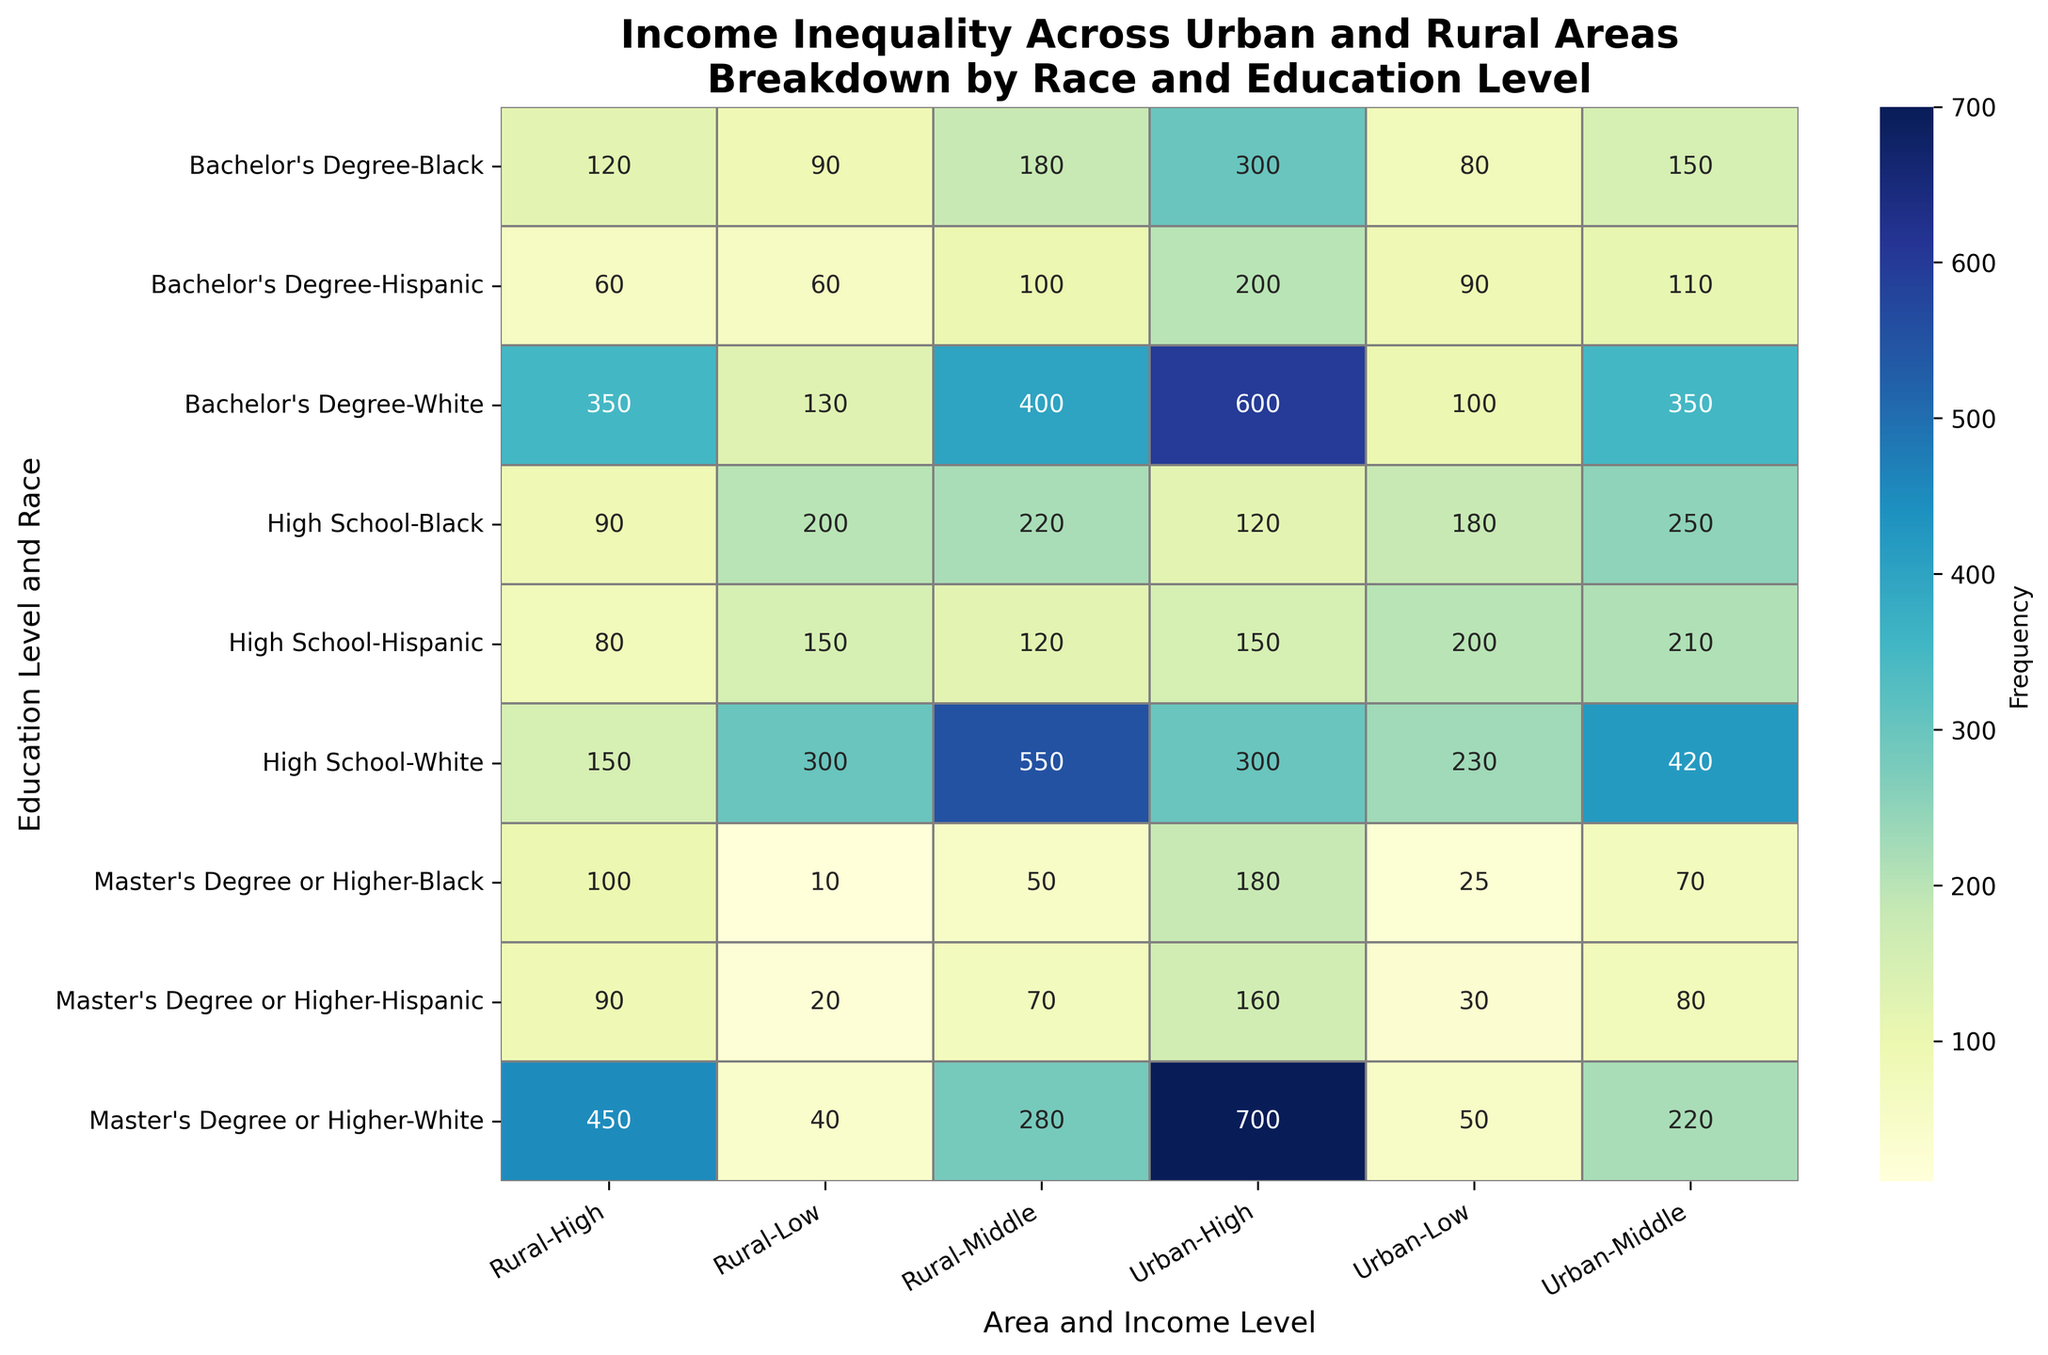Which race has the highest income level among urban residents with a Master's Degree or Higher? By looking at the cells in the 'Urban' column for residents with a Master's Degree or Higher across different races, the White race shows the highest frequency value under the 'High' income level with 700.
Answer: White How does the number of rural Black residents with a high school education and low-income compare to the number of urban Black residents with a high school education and low-income? Look at the cells where the education level is 'High School', and the income level is 'Low'. In the 'Rural' column, the frequency for Black residents is 200. In the 'Urban' column, it is 180. Comparing these, the rural frequency is 20 more than the urban frequency.
Answer: Rural has 20 more Which area and educational level combination have the lowest frequency of high-income Hispanic residents? The lowest frequency among all the 'High' income Hispanic residents across both urban and rural areas and all educational levels is 60 seen in the rural Bachelor's Degree category.
Answer: Rural, Bachelor's Degree What is the total number of Black residents with a low-income in both urban and rural areas combined? Add the frequencies for Black residents with 'Low' income in both Urban and Rural areas. Urban count is 180 (High School) + 80 (Bachelor’s Degree) + 25 (Master's Degree or Higher). Rural count is 200 (High School) + 90 (Bachelor’s Degree) + 10 (Master's Degree or Higher). Therefore: 180 + 80 + 25 + 200 + 90 + 10 = 585.
Answer: 585 Which group has a higher proportion of middle-income vs low-income, urban or rural Hispanic residents with a Bachelor's Degree? Calculate the ratios for both 'Urban' and 'Rural' Hispanic residents with Bachelor's Degrees. Urban: Middle (110) / Low (90) = 110/90 ≈ 1.22. Rural: Middle (100) / Low (60) = 100/60 ≈ 1.67. The rural proportion is higher.
Answer: Rural Comparing urban and rural areas, which area has more bachelor's degree Black residents in middle-income category? Check the frequency for Black residents with Bachelor's Degrees and Middle income in both Urban and Rural areas. Urban has 150 and Rural has 180. Therefore, rural area has more.
Answer: Rural What is the sum of the frequencies for high-income urban residents with a Bachelor's Degree, regardless of race? Add all the frequencies in the 'High' income level for all races in the 'Urban' area with a Bachelor's Degree. White: 600, Black: 300, Hispanic: 200. Therefore, 600 + 300 + 200 = 1100.
Answer: 1100 